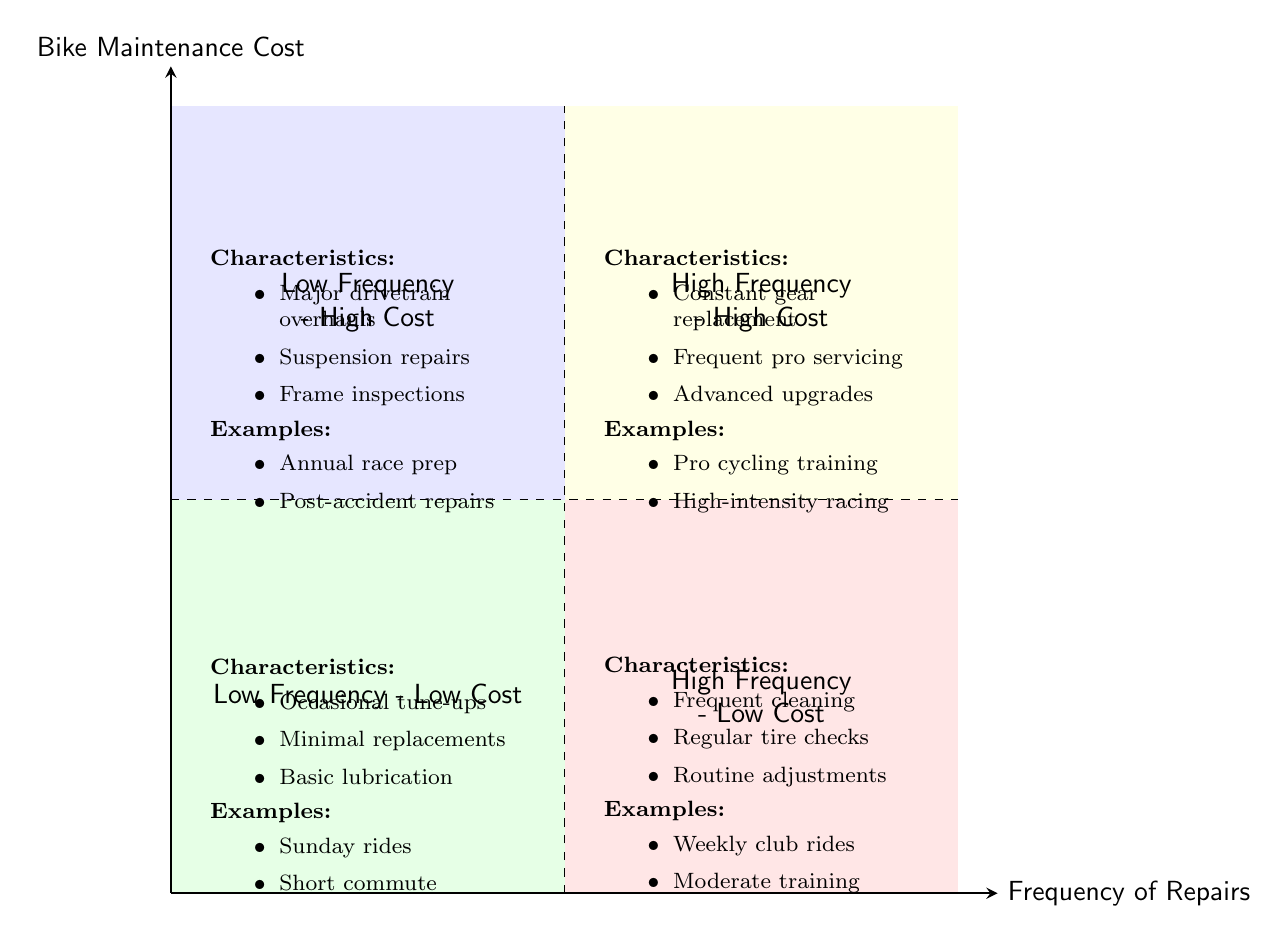What are the characteristics of the High Frequency - Low Cost quadrant? The High Frequency - Low Cost quadrant is located in the bottom right. Its characteristics include frequent cleaning, regular tire checks and pumping, and routine brake adjustments.
Answer: Frequent cleaning, regular tire checks and pumping, routine brake adjustments What kind of bike maintenance is typical in the Low Frequency - High Cost quadrant? The Low Frequency - High Cost quadrant is in the top left. It includes major drivetrain overhauls, suspension repairs, and frame inspections and cracks.
Answer: Major drivetrain overhauls, suspension repairs, frame inspections In which quadrant would you find pro cycling training? Pro cycling training is mentioned as an example in the High Frequency - High Cost quadrant, which is located in the top right.
Answer: High Frequency - High Cost How many examples are provided for the Low Frequency - Low Cost quadrant? The Low Frequency - Low Cost quadrant lists two examples: Sunday rides and short commute, indicating a total of two examples.
Answer: 2 Which quadrant contains the term "Annual race season prep"? "Annual race season prep" is an example found in the Low Frequency - High Cost quadrant located in the top left.
Answer: Low Frequency - High Cost What is the main focus of the High Frequency - High Cost quadrant? The High Frequency - High Cost quadrant emphasizes constant gear replacement, frequent professional servicing, and advanced component upgrades, focusing on high levels of maintenance and cost.
Answer: Constant gear replacement, frequent professional servicing, advanced component upgrades Which quadrant corresponds to minimal bike maintenance costs? The quadrant with minimal bike maintenance costs is the Low Frequency - Low Cost quadrant, located in the bottom left, where maintenance is occasional and basic.
Answer: Low Frequency - Low Cost How would you describe the maintenance examples in the High Frequency - Low Cost quadrant? The maintenance examples for the High Frequency - Low Cost quadrant, including weekly club rides and moderate training, suggest regular but low-cost maintenance practices.
Answer: Weekly club rides, moderate training 